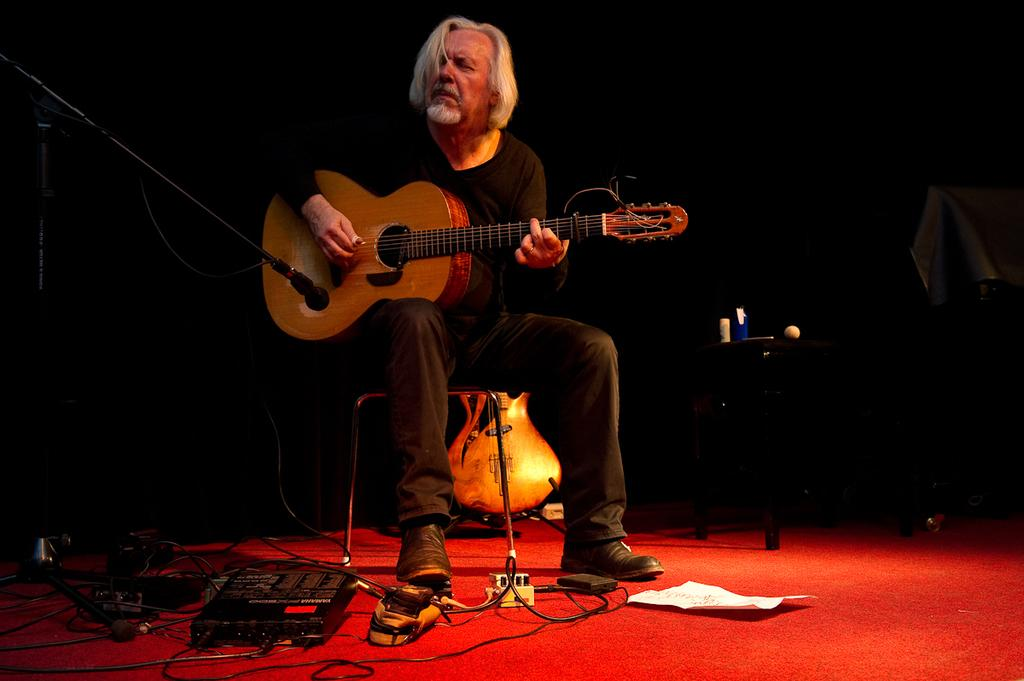What is the man in the image doing? The man is sitting on a chair and holding a guitar. What object is connected to cables in the image? There is an electronic device with cables in the image. What is on the floor in the image? There is a paper on the floor. What piece of furniture is present in the image? There is a table in the image. What device is used for amplifying sound in the image? There is a microphone with a mic holder in the image. What type of expert is giving a lecture in the image? There is no expert giving a lecture in the image; it features a man holding a guitar and other related objects. What kind of ray is visible in the image? There is no ray present in the image. 